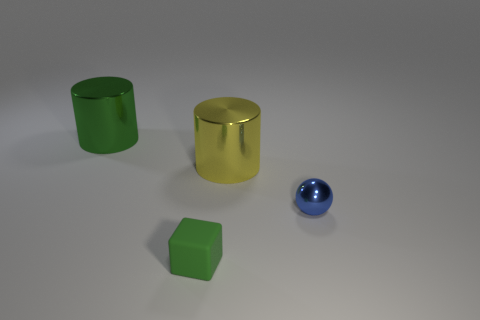Add 4 tiny cyan cubes. How many objects exist? 8 Subtract all tiny green matte cubes. Subtract all big green shiny things. How many objects are left? 2 Add 4 tiny green objects. How many tiny green objects are left? 5 Add 2 large gray metallic blocks. How many large gray metallic blocks exist? 2 Subtract 0 brown cylinders. How many objects are left? 4 